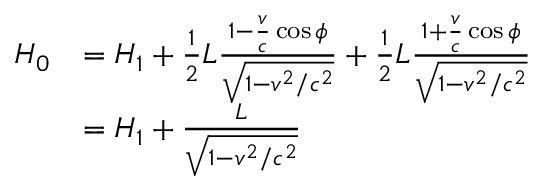<formula> <loc_0><loc_0><loc_500><loc_500>{ \begin{array} { r l } { H _ { 0 } } & { = H _ { 1 } + { \frac { 1 } { 2 } } L { \frac { 1 - { \frac { v } { c } } \cos { \phi } } { \sqrt { 1 - v ^ { 2 } / c ^ { 2 } } } } + { \frac { 1 } { 2 } } L { \frac { 1 + { \frac { v } { c } } \cos { \phi } } { \sqrt { 1 - v ^ { 2 } / c ^ { 2 } } } } } \\ & { = H _ { 1 } + { \frac { L } { \sqrt { 1 - v ^ { 2 } / c ^ { 2 } } } } } \end{array} }</formula> 